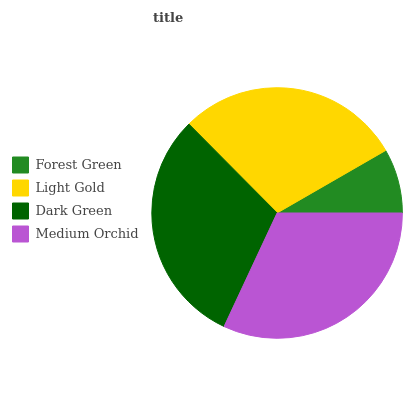Is Forest Green the minimum?
Answer yes or no. Yes. Is Medium Orchid the maximum?
Answer yes or no. Yes. Is Light Gold the minimum?
Answer yes or no. No. Is Light Gold the maximum?
Answer yes or no. No. Is Light Gold greater than Forest Green?
Answer yes or no. Yes. Is Forest Green less than Light Gold?
Answer yes or no. Yes. Is Forest Green greater than Light Gold?
Answer yes or no. No. Is Light Gold less than Forest Green?
Answer yes or no. No. Is Dark Green the high median?
Answer yes or no. Yes. Is Light Gold the low median?
Answer yes or no. Yes. Is Light Gold the high median?
Answer yes or no. No. Is Forest Green the low median?
Answer yes or no. No. 